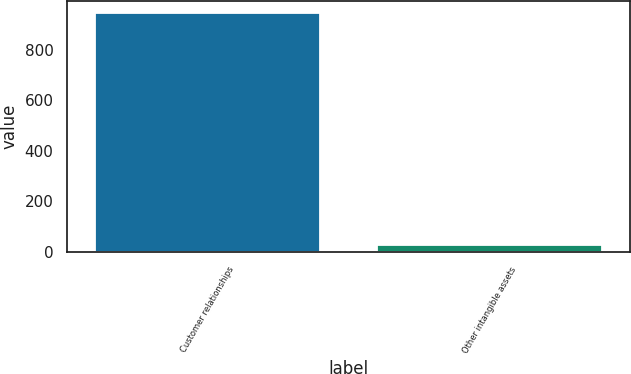Convert chart to OTSL. <chart><loc_0><loc_0><loc_500><loc_500><bar_chart><fcel>Customer relationships<fcel>Other intangible assets<nl><fcel>944<fcel>29<nl></chart> 